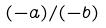Convert formula to latex. <formula><loc_0><loc_0><loc_500><loc_500>( - a ) / ( - b )</formula> 